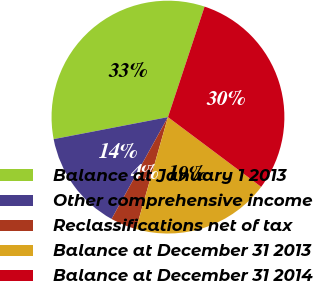Convert chart. <chart><loc_0><loc_0><loc_500><loc_500><pie_chart><fcel>Balance at January 1 2013<fcel>Other comprehensive income<fcel>Reclassifications net of tax<fcel>Balance at December 31 2013<fcel>Balance at December 31 2014<nl><fcel>33.12%<fcel>13.92%<fcel>3.62%<fcel>19.2%<fcel>30.14%<nl></chart> 